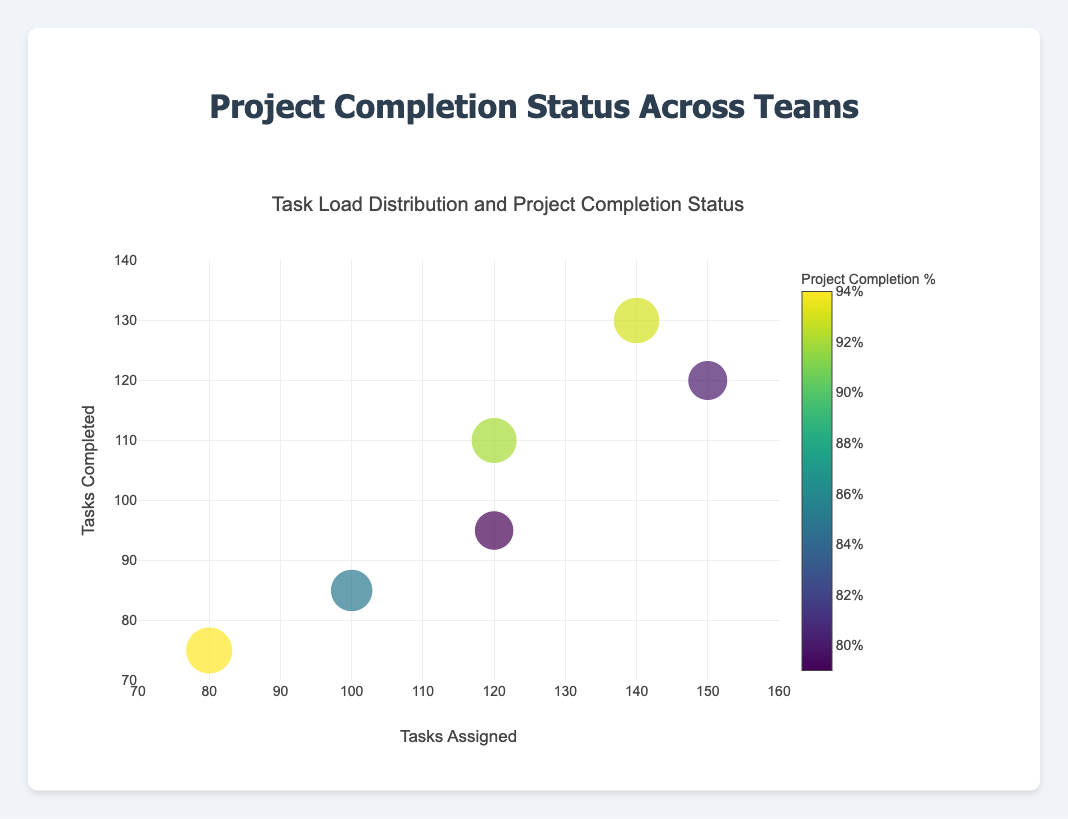What is the title of the chart? The title of the chart is displayed at the top. It specifies the focus of the chart.
Answer: Project Completion Status Across Teams How many teams are represented in the chart? By counting all the unique data points (bubbles) in the chart and referring to the data, we can see each bubble represents a team.
Answer: Six Which team has the highest completion percentage? The color bar indicates the completion percentage, and by identifying the team with the darkest color near the highest value on the color scale, we can find this team.
Answer: Echo Which team has the largest task workload assigned to them? By looking at the x-axis which represents Tasks Assigned and identifying the bubble farthest to the right, we can determine this team.
Answer: Alpha Which team has completed the least tasks? By looking at the y-axis which represents Tasks Completed and identifying the bubble with the lowest y-value, we can find this team.
Answer: Echo What is the range of tasks assigned across all the teams? Determine the minimum and maximum values on the x-axis that represent the tasks assigned to all teams, from the smallest to the largest value.
Answer: 80 to 150 Which teams have completed more than 90 tasks? By looking at the y-axis, identify the bubbles that are above the 90 mark and refer to their corresponding team names in the hover text or data.
Answer: Alpha, Bravo, Charlie, Delta, Foxtrot Compare the project completion percentages between Team Charlie and Team Delta. Which one is higher? Refer to the color intensity for these teams or check the hover text for precise values and compare.
Answer: Delta What is the approximate average of tasks completed by all teams? Sum up the tasks completed by each team and then divide by the number of teams: (120 + 85 + 95 + 110 + 75 + 130) / 6 = 615 / 6
Answer: 102.5 What is the size of the bubble representing Team Foxtrot? The size of the bubble correlates with the completion percentage, and the specific size value can be checked in the hover text or indirectly inferred from the marker size setting (half of the completion percentage).
Answer: 46.5 (half of 93) 